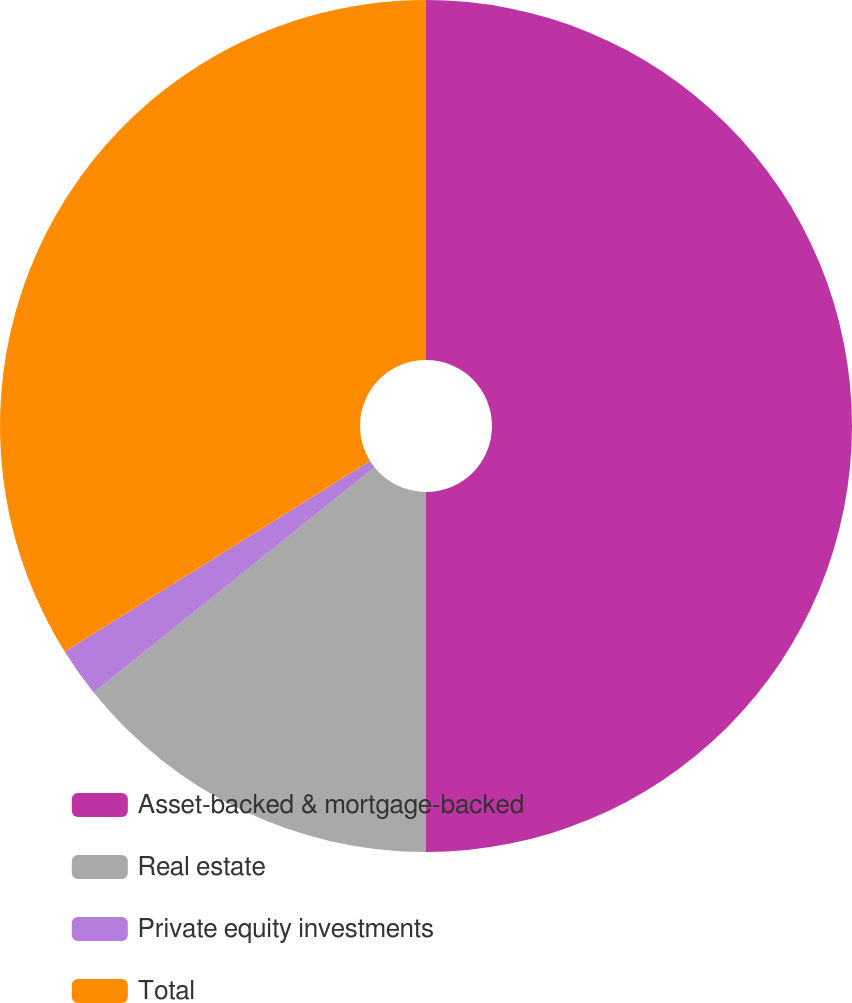Convert chart to OTSL. <chart><loc_0><loc_0><loc_500><loc_500><pie_chart><fcel>Asset-backed & mortgage-backed<fcel>Real estate<fcel>Private equity investments<fcel>Total<nl><fcel>50.0%<fcel>14.24%<fcel>1.87%<fcel>33.89%<nl></chart> 